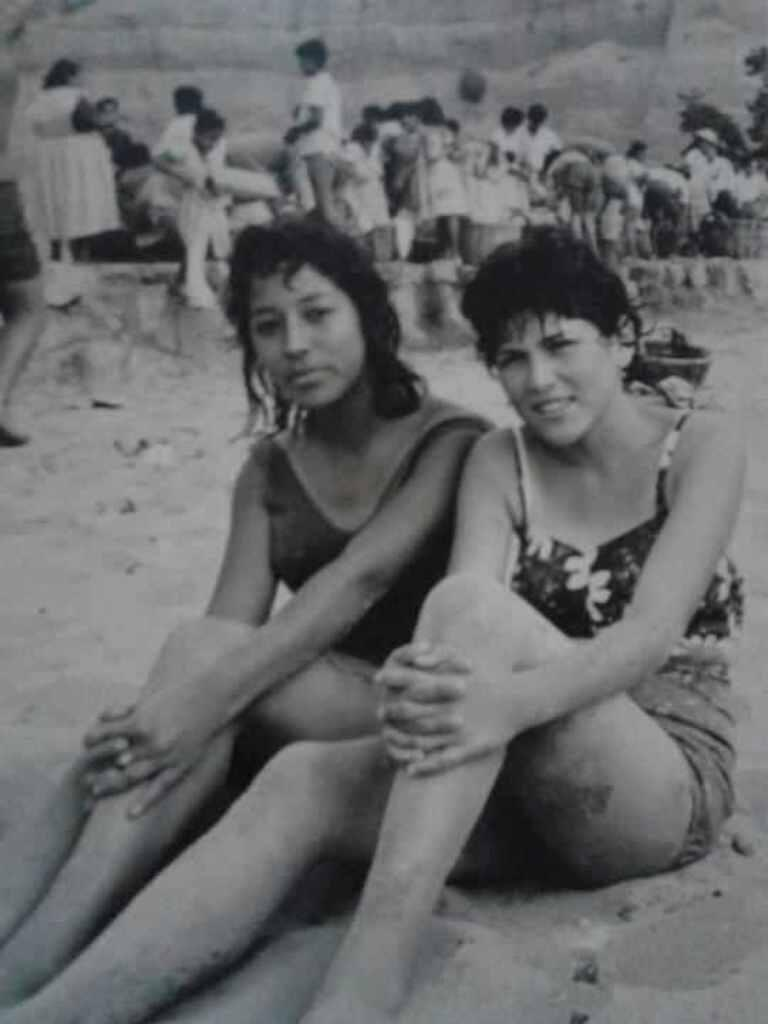How many people can be seen in the image? There are many people in the image. Can you describe the position of the two women in the image? Two women are sitting on the sand at the front of the image. What type of surface is at the bottom of the image? There is sand at the bottom of the image. What can be seen in the background of the image? There are many people in the background of the image. What type of hammer is being used by the person in the image? There is no hammer present in the image. How does the rose contribute to the purpose of the gathering in the image? There is no rose or gathering present in the image. 